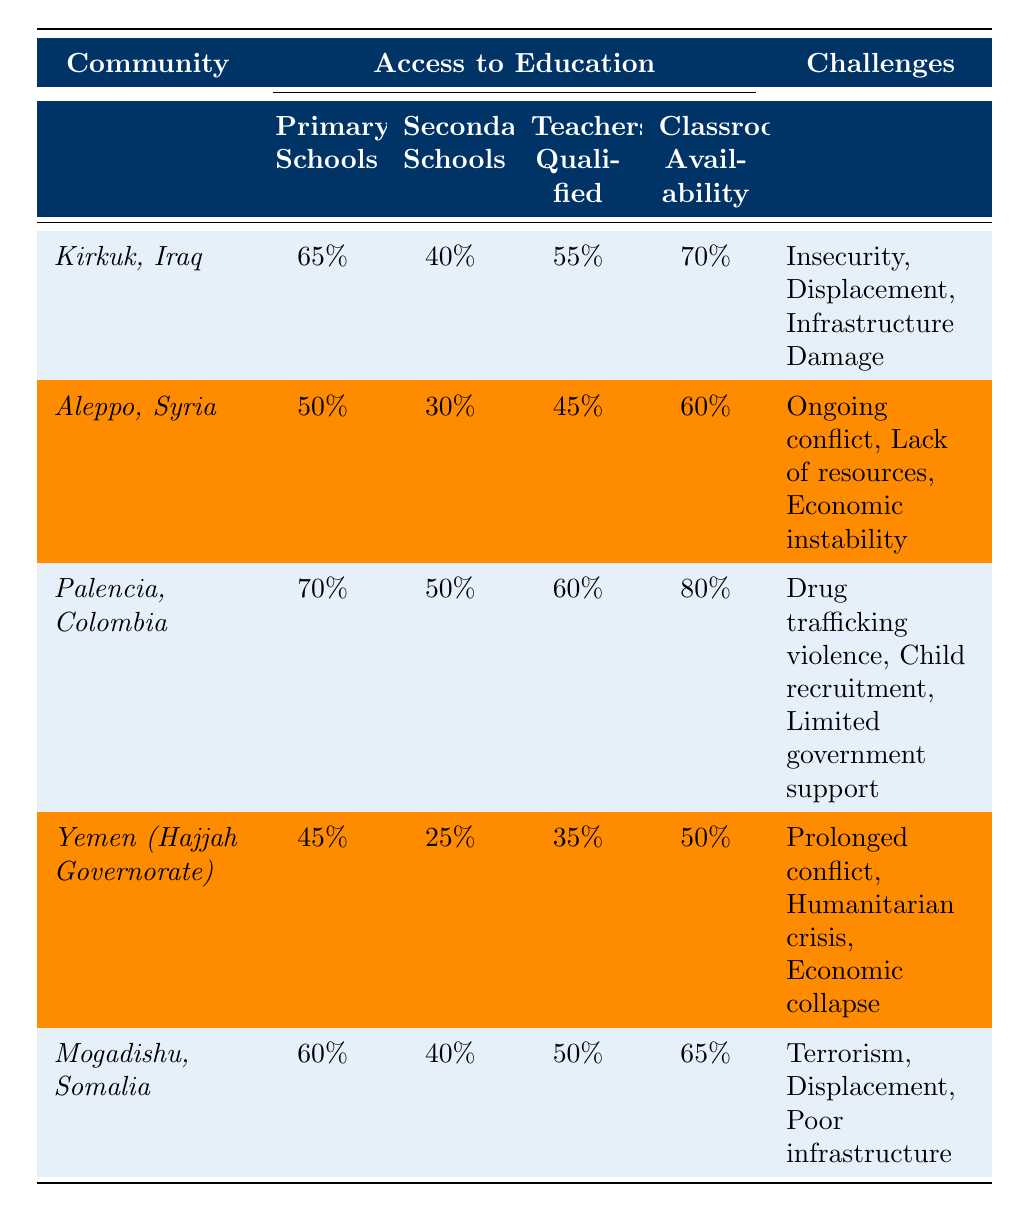What is the percentage of primary schools in Aleppo, Syria? Looking at the table, the percentage of primary schools in Aleppo, Syria is listed as 50%.
Answer: 50% Which community has the highest percentage of teachers qualified? By reviewing the table, Palencia, Colombia has the highest percentage of qualified teachers at 60%.
Answer: 60% Calculate the average percentage of classroom availability across all listed communities. The percentages for classroom availability are 70%, 60%, 80%, 50%, and 65%. Adding these values (70 + 60 + 80 + 50 + 65) = 325; dividing by the number of communities (5) gives an average of 325/5 = 65%.
Answer: 65% In which community is the access to secondary schools the lowest? The table indicates that Yemen (Hajjah Governorate) has the lowest percentage of access to secondary schools at 25%.
Answer: Yemen (Hajjah Governorate) True or False: The classroom availability in Kirkuk, Iraq is greater than that in Aleppo, Syria. The table shows classroom availability in Kirkuk, Iraq is 70% and in Aleppo, Syria is 60%. Since 70% is greater than 60%, the statement is true.
Answer: True What challenge do both Kirkuk, Iraq and Mogadishu, Somalia share? Both communities list "Displacement" as a challenge in the table.
Answer: Displacement How does the percentage of secondary schools in Yemen compare with that in Palencia, Colombia? The percentage of secondary schools in Yemen is 25%, while in Palencia, Colombia it is 50%. Therefore, Palencia has 25% more access to secondary schools than Yemen.
Answer: 25% Which community shows the most challenging conditions according to the table? Based on the listed challenges in the table, Yemen (Hajjah Governorate) depicts the most severe challenges with “Prolonged conflict, Humanitarian crisis, Economic collapse”.
Answer: Yemen (Hajjah Governorate) What is the difference in percentage of primary schools between Palencia, Colombia and Aleppo, Syria? The percentage of primary schools in Palencia, Colombia is 70% and in Aleppo, Syria is 50%. The difference is 70% - 50% = 20%.
Answer: 20% Are there more teachers qualified in Kirkuk, Iraq or in Mogadishu, Somalia? The table states that Kirkuk has 55% qualified teachers, whereas Mogadishu has 50%. Kirkuk has more qualified teachers.
Answer: Kirkuk, Iraq If we were to rank the communities by percentage of primary schools from highest to lowest, which community would come second? The ranking of communities by percentage of primary schools shows Palencia (70%), Kirkuk (65%), Aleppo (50%), Mogadishu (60%), and Yemen (45%). Thus, Kirkuk, Iraq comes second.
Answer: Kirkuk, Iraq 